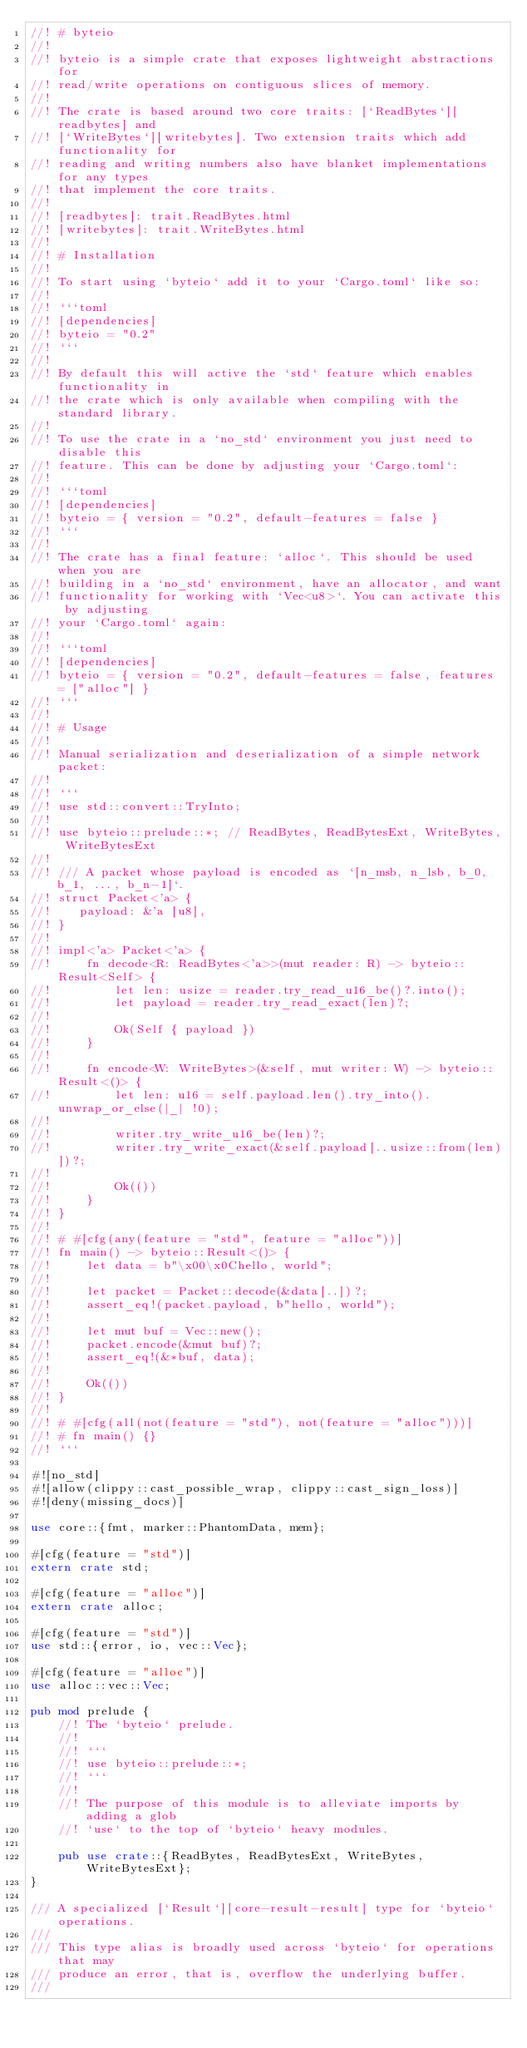Convert code to text. <code><loc_0><loc_0><loc_500><loc_500><_Rust_>//! # byteio
//!
//! byteio is a simple crate that exposes lightweight abstractions for
//! read/write operations on contiguous slices of memory.
//!
//! The crate is based around two core traits: [`ReadBytes`][readbytes] and
//! [`WriteBytes`][writebytes]. Two extension traits which add functionality for
//! reading and writing numbers also have blanket implementations for any types
//! that implement the core traits.
//!
//! [readbytes]: trait.ReadBytes.html
//! [writebytes]: trait.WriteBytes.html
//!
//! # Installation
//!
//! To start using `byteio` add it to your `Cargo.toml` like so:
//!
//! ```toml
//! [dependencies]
//! byteio = "0.2"
//! ```
//!
//! By default this will active the `std` feature which enables functionality in
//! the crate which is only available when compiling with the standard library.
//!
//! To use the crate in a `no_std` environment you just need to disable this
//! feature. This can be done by adjusting your `Cargo.toml`:
//!
//! ```toml
//! [dependencies]
//! byteio = { version = "0.2", default-features = false }
//! ```
//!
//! The crate has a final feature: `alloc`. This should be used when you are
//! building in a `no_std` environment, have an allocator, and want
//! functionality for working with `Vec<u8>`. You can activate this by adjusting
//! your `Cargo.toml` again:
//!
//! ```toml
//! [dependencies]
//! byteio = { version = "0.2", default-features = false, features = ["alloc"] }
//! ```
//!
//! # Usage
//!
//! Manual serialization and deserialization of a simple network packet:
//!
//! ```
//! use std::convert::TryInto;
//!
//! use byteio::prelude::*; // ReadBytes, ReadBytesExt, WriteBytes, WriteBytesExt
//!
//! /// A packet whose payload is encoded as `[n_msb, n_lsb, b_0, b_1, ..., b_n-1]`.
//! struct Packet<'a> {
//!    payload: &'a [u8],
//! }
//!
//! impl<'a> Packet<'a> {
//!     fn decode<R: ReadBytes<'a>>(mut reader: R) -> byteio::Result<Self> {
//!         let len: usize = reader.try_read_u16_be()?.into();
//!         let payload = reader.try_read_exact(len)?;
//!
//!         Ok(Self { payload })
//!     }
//!
//!     fn encode<W: WriteBytes>(&self, mut writer: W) -> byteio::Result<()> {
//!         let len: u16 = self.payload.len().try_into().unwrap_or_else(|_| !0);
//!
//!         writer.try_write_u16_be(len)?;
//!         writer.try_write_exact(&self.payload[..usize::from(len)])?;
//!
//!         Ok(())
//!     }
//! }
//!
//! # #[cfg(any(feature = "std", feature = "alloc"))]
//! fn main() -> byteio::Result<()> {
//!     let data = b"\x00\x0Chello, world";
//!
//!     let packet = Packet::decode(&data[..])?;
//!     assert_eq!(packet.payload, b"hello, world");
//!
//!     let mut buf = Vec::new();
//!     packet.encode(&mut buf)?;
//!     assert_eq!(&*buf, data);
//!
//!     Ok(())
//! }
//!
//! # #[cfg(all(not(feature = "std"), not(feature = "alloc")))]
//! # fn main() {}
//! ```

#![no_std]
#![allow(clippy::cast_possible_wrap, clippy::cast_sign_loss)]
#![deny(missing_docs)]

use core::{fmt, marker::PhantomData, mem};

#[cfg(feature = "std")]
extern crate std;

#[cfg(feature = "alloc")]
extern crate alloc;

#[cfg(feature = "std")]
use std::{error, io, vec::Vec};

#[cfg(feature = "alloc")]
use alloc::vec::Vec;

pub mod prelude {
    //! The `byteio` prelude.
    //!
    //! ```
    //! use byteio::prelude::*;
    //! ```
    //!
    //! The purpose of this module is to alleviate imports by adding a glob
    //! `use` to the top of `byteio` heavy modules.

    pub use crate::{ReadBytes, ReadBytesExt, WriteBytes, WriteBytesExt};
}

/// A specialized [`Result`][core-result-result] type for `byteio` operations.
///
/// This type alias is broadly used across `byteio` for operations that may
/// produce an error, that is, overflow the underlying buffer.
///</code> 